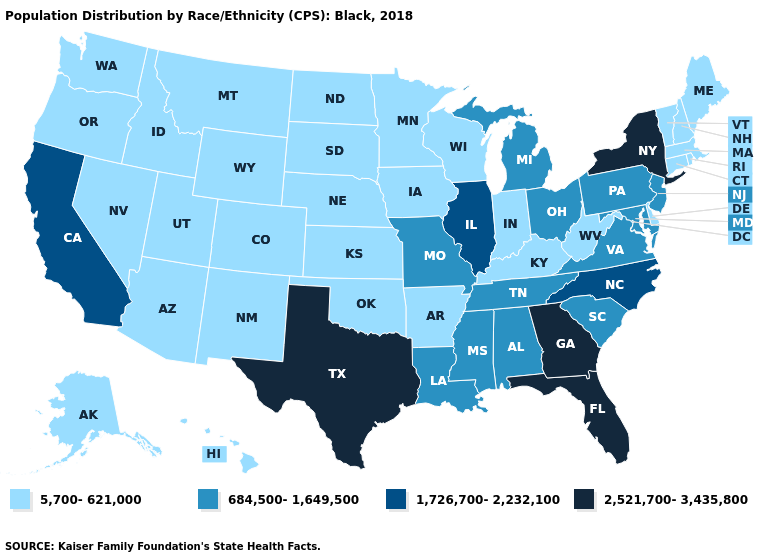Among the states that border Alabama , which have the lowest value?
Short answer required. Mississippi, Tennessee. Name the states that have a value in the range 684,500-1,649,500?
Give a very brief answer. Alabama, Louisiana, Maryland, Michigan, Mississippi, Missouri, New Jersey, Ohio, Pennsylvania, South Carolina, Tennessee, Virginia. How many symbols are there in the legend?
Give a very brief answer. 4. Name the states that have a value in the range 5,700-621,000?
Write a very short answer. Alaska, Arizona, Arkansas, Colorado, Connecticut, Delaware, Hawaii, Idaho, Indiana, Iowa, Kansas, Kentucky, Maine, Massachusetts, Minnesota, Montana, Nebraska, Nevada, New Hampshire, New Mexico, North Dakota, Oklahoma, Oregon, Rhode Island, South Dakota, Utah, Vermont, Washington, West Virginia, Wisconsin, Wyoming. Does Maryland have the highest value in the USA?
Concise answer only. No. Does Washington have the lowest value in the West?
Quick response, please. Yes. Name the states that have a value in the range 5,700-621,000?
Answer briefly. Alaska, Arizona, Arkansas, Colorado, Connecticut, Delaware, Hawaii, Idaho, Indiana, Iowa, Kansas, Kentucky, Maine, Massachusetts, Minnesota, Montana, Nebraska, Nevada, New Hampshire, New Mexico, North Dakota, Oklahoma, Oregon, Rhode Island, South Dakota, Utah, Vermont, Washington, West Virginia, Wisconsin, Wyoming. Among the states that border Nevada , which have the lowest value?
Quick response, please. Arizona, Idaho, Oregon, Utah. Does Oklahoma have the lowest value in the South?
Write a very short answer. Yes. What is the value of Arizona?
Be succinct. 5,700-621,000. Name the states that have a value in the range 1,726,700-2,232,100?
Write a very short answer. California, Illinois, North Carolina. Does the first symbol in the legend represent the smallest category?
Write a very short answer. Yes. Does New Hampshire have the same value as Connecticut?
Concise answer only. Yes. Name the states that have a value in the range 1,726,700-2,232,100?
Give a very brief answer. California, Illinois, North Carolina. 